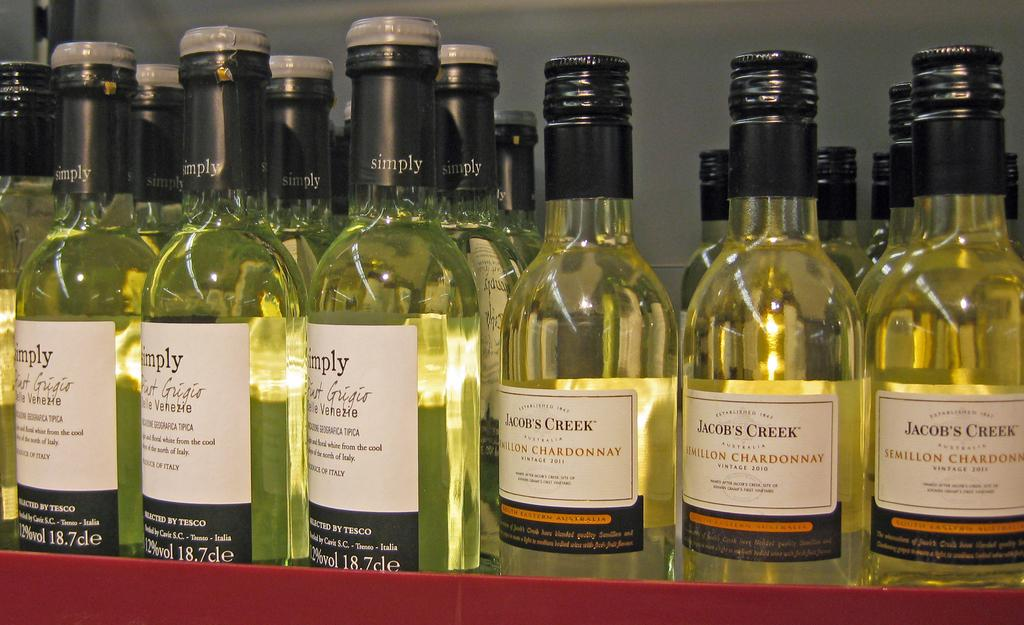What objects can be seen in the image? There are bottles in the image. What distinguishing features do the bottles have? The bottles have labels on them. Where is the nearest park to the location of the bottles in the image? The provided facts do not give any information about the location of the bottles or the presence of a park, so it is not possible to answer this question. 